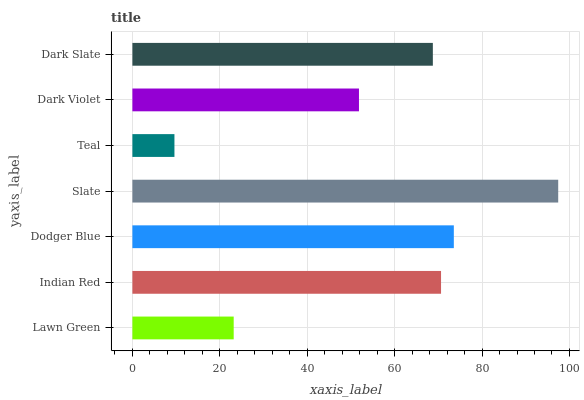Is Teal the minimum?
Answer yes or no. Yes. Is Slate the maximum?
Answer yes or no. Yes. Is Indian Red the minimum?
Answer yes or no. No. Is Indian Red the maximum?
Answer yes or no. No. Is Indian Red greater than Lawn Green?
Answer yes or no. Yes. Is Lawn Green less than Indian Red?
Answer yes or no. Yes. Is Lawn Green greater than Indian Red?
Answer yes or no. No. Is Indian Red less than Lawn Green?
Answer yes or no. No. Is Dark Slate the high median?
Answer yes or no. Yes. Is Dark Slate the low median?
Answer yes or no. Yes. Is Slate the high median?
Answer yes or no. No. Is Dark Violet the low median?
Answer yes or no. No. 